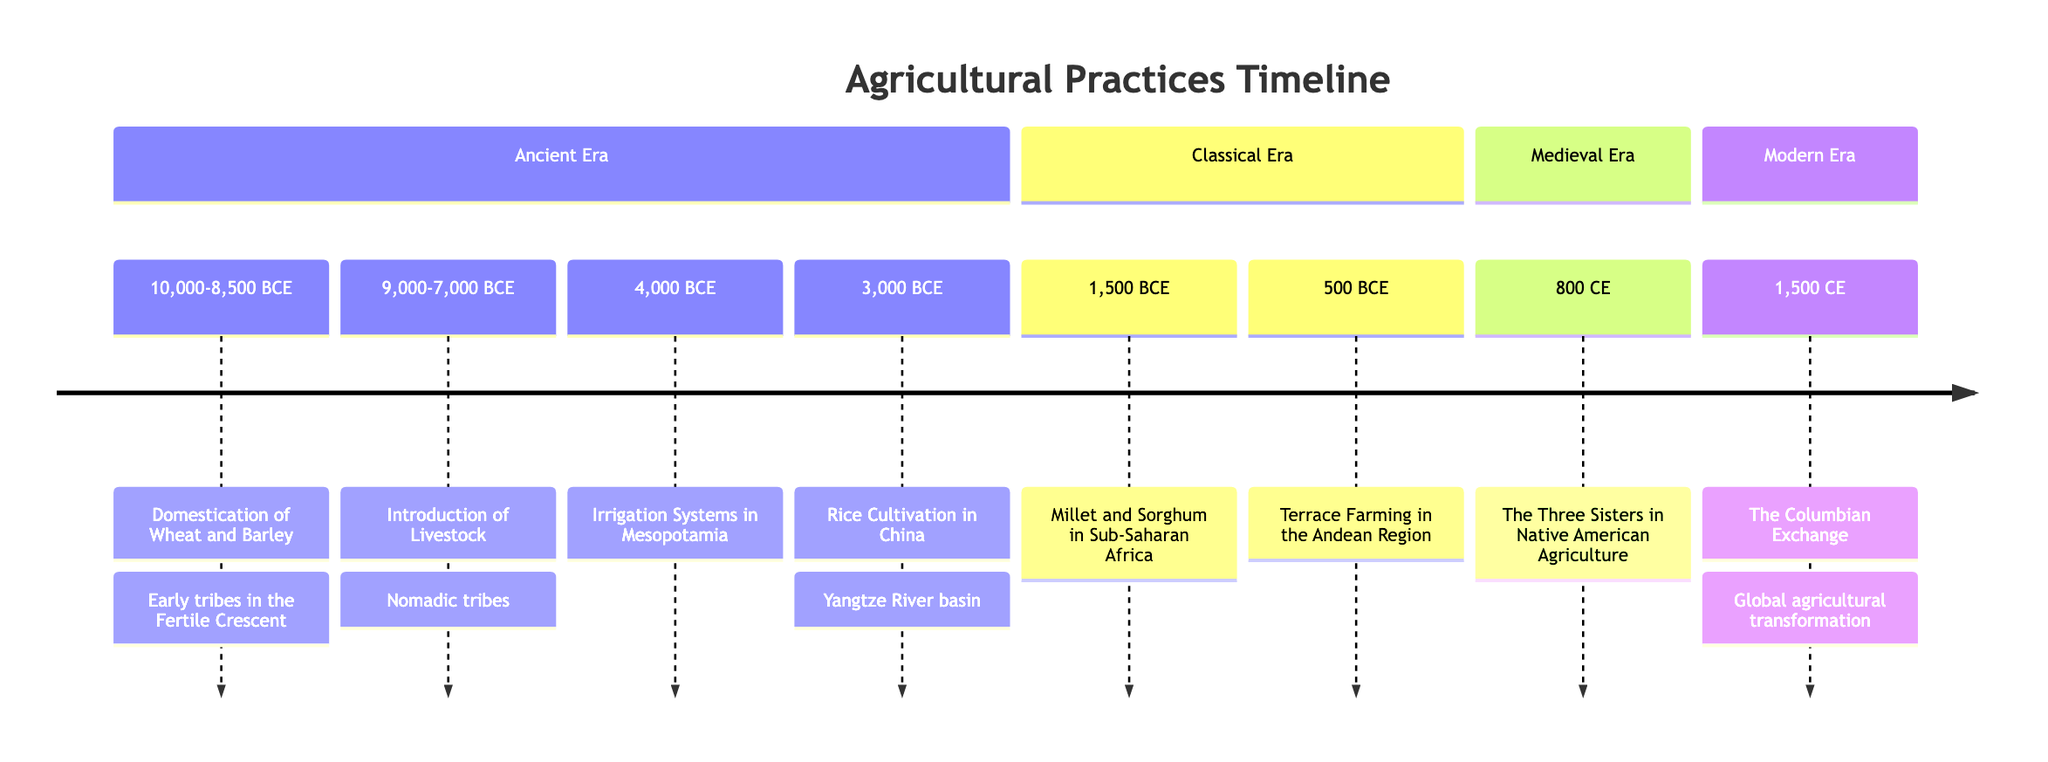What event marks the beginning of the timeline? The timeline starts with the domestication of wheat and barley, which occurred between 10,000 and 8,500 BCE. This is the first significant event listed.
Answer: Domestication of Wheat and Barley How many significant agricultural practices are listed in the timeline? By counting each event presented in the timeline, there are a total of eight significant agricultural practices detailed.
Answer: 8 Which agricultural practice was introduced around 1,500 BCE? The event listed for 1,500 BCE is the cultivation of millet and sorghum in Sub-Saharan Africa. This is directly stated in the timeline.
Answer: Millet and Sorghum in Sub-Saharan Africa What is the period in which the Three Sisters agriculture was practiced? The Three Sisters agriculture was introduced in 800 CE, as indicated in the timeline.
Answer: 800 CE What was developed in Mesopotamia around 4,000 BCE? The timeline states that in 4,000 BCE, irrigation systems were developed in Mesopotamia, enhancing agricultural productivity.
Answer: Irrigation Systems in Mesopotamia Which crops were transformed due to the Columbian Exchange? The timeline mentions that the Columbian Exchange transformed global agriculture by exchanging crops like potatoes, tomatoes, and maize.
Answer: Potatoes, tomatoes, and maize What was a major adaptation for tribes in Sub-Saharan Africa around 1,500 BCE? Sub-Saharan tribes began cultivating drought-resistant crops, specifically millet and sorghum, adapting to their arid environment.
Answer: Drought-resistant crops How did the introduction of livestock influence nomadic tribes? The introduction of livestock allowed nomadic tribes to domesticate animals for meat, milk, and wool, enhancing their food resources and lifestyle.
Answer: Meat, milk, and wool 